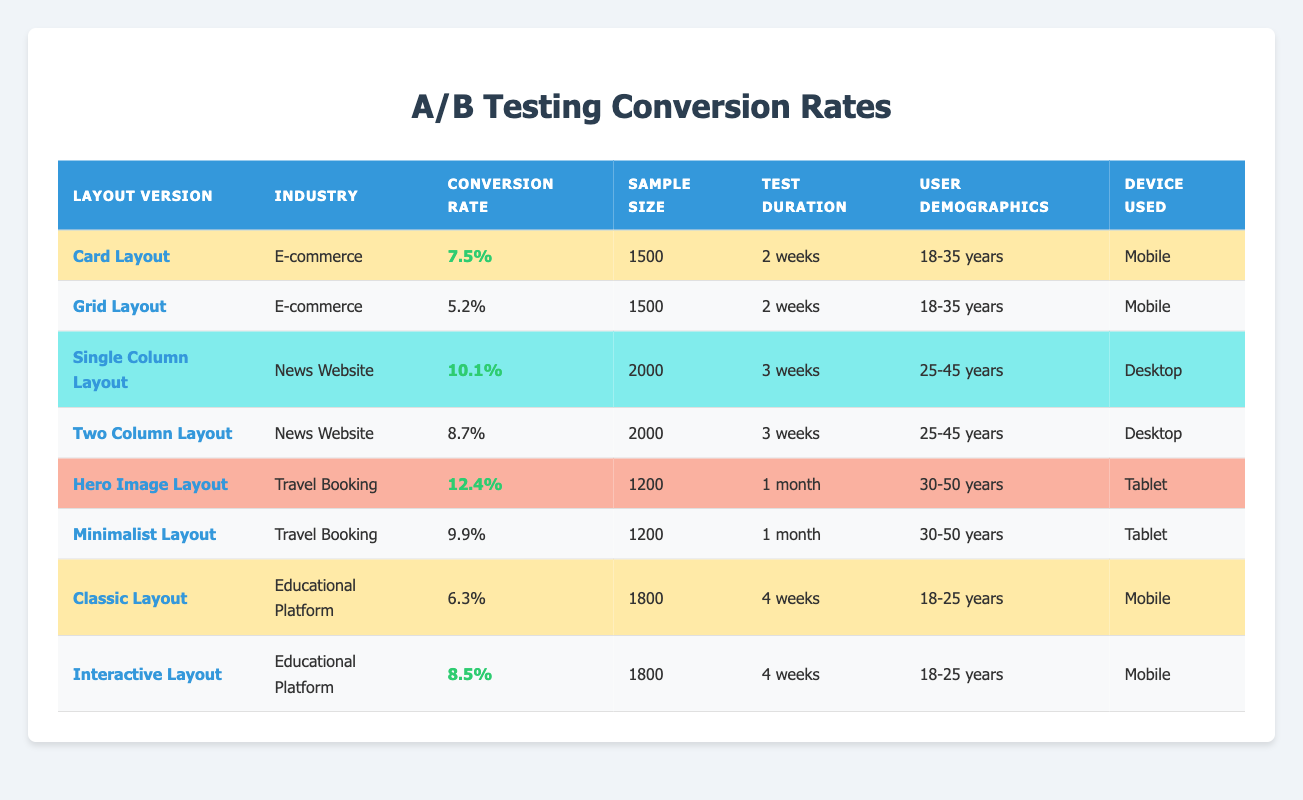What is the conversion rate for the "Hero Image Layout"? The conversion rate for the "Hero Image Layout" can be found in the table under the corresponding layout version, which shows a conversion rate of 12.4%.
Answer: 12.4% Which layout version had the highest conversion rate? According to the table, the "Hero Image Layout" has the highest conversion rate of 12.4% compared to all the other layout versions listed.
Answer: Hero Image Layout What is the conversion rate difference between the "Single Column Layout" and the "Two Column Layout"? The conversion rate for the "Single Column Layout" is 10.1% and for the "Two Column Layout" is 8.7%. The difference is calculated as 10.1% - 8.7% = 1.4%.
Answer: 1.4% Which layout version has the lowest conversion rate? Reviewing the table, the "Grid Layout" shows the lowest conversion rate at 5.2% among all the layout versions.
Answer: Grid Layout What percentage of the sample size was used for the "Card Layout"? The sample size for the "Card Layout" is 1500, which is explicitly stated in the corresponding row of the table.
Answer: 1500 Is the "Interactive Layout" more effective than the "Classic Layout"? By looking at the conversion rates, the "Interactive Layout" has a conversion rate of 8.5%, while the "Classic Layout" has 6.3%. Since 8.5% is greater than 6.3%, the "Interactive Layout" is indeed more effective.
Answer: Yes How many weeks did the "Hero Image Layout" run for the A/B test? The test duration for the "Hero Image Layout" is stated clearly in the table as 1 month, which is equivalent to approximately 4 weeks.
Answer: 4 weeks What is the average conversion rate for the layouts used in the E-commerce industry? The conversion rates for the layouts in E-commerce are 7.5% (Card Layout) and 5.2% (Grid Layout). To find the average, we add them: 7.5% + 5.2% = 12.7%, then divide by 2 to get 12.7% / 2 = 6.35%.
Answer: 6.35% Do all the layout versions have the same user demographics? The user demographics vary across the layout versions. "Card Layout" and "Grid Layout" target users aged 18-35, while the "Single Column Layout" and "Two Column Layout" target users aged 25-45, and so on. Therefore, not all layout versions share the same demographics.
Answer: No In which layout versions was the sample size less than 2000? The "Card Layout" and the "Hero Image Layout" had sample sizes of 1500 and 1200 respectively, both less than 2000.
Answer: Card Layout, Hero Image Layout 